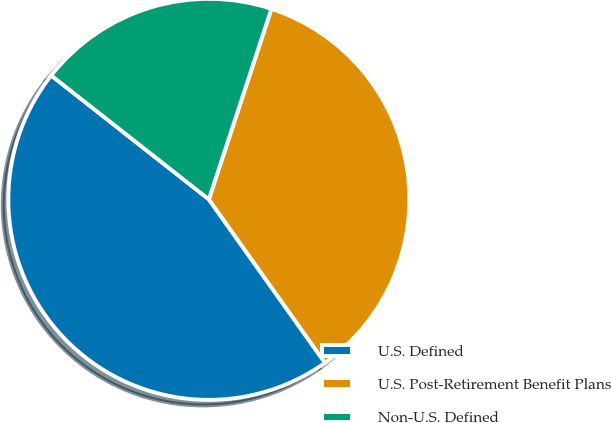Convert chart to OTSL. <chart><loc_0><loc_0><loc_500><loc_500><pie_chart><fcel>U.S. Defined<fcel>U.S. Post-Retirement Benefit Plans<fcel>Non-U.S. Defined<nl><fcel>45.43%<fcel>35.12%<fcel>19.45%<nl></chart> 